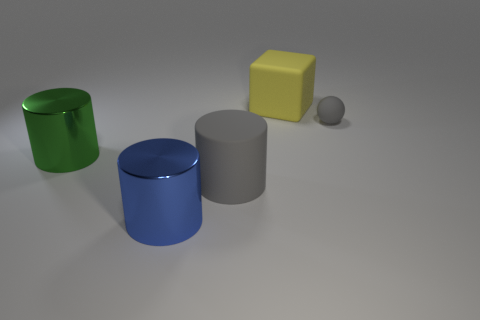Imagine these objects are part of a child’s toy set. What sort of game might they be used for? These objects could be used in a variety of imaginative play scenarios. For instance, they could serve as pieces in a sorting and stacking game, where a child is tasked with arranging them by size, color, or shape. Alternatively, they could be used in a make-believe setting as various structures or vehicles in a miniature toy landscape. 